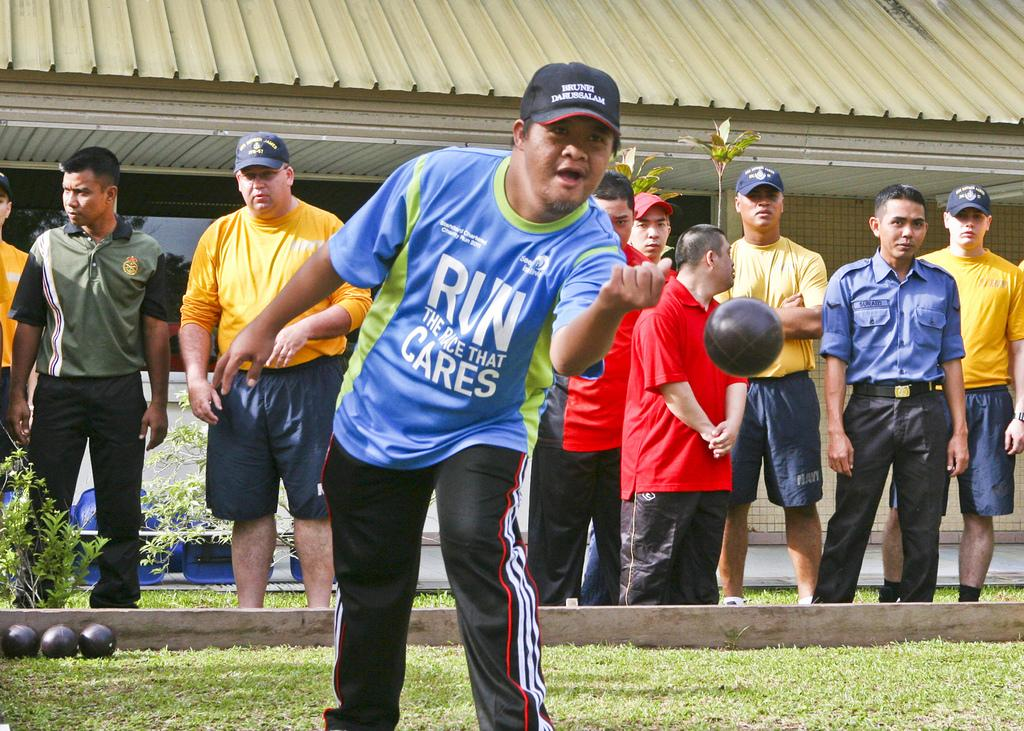<image>
Share a concise interpretation of the image provided. Athlete featured is playing Bocce Ball, his shirt says Run The Race that Cares. 